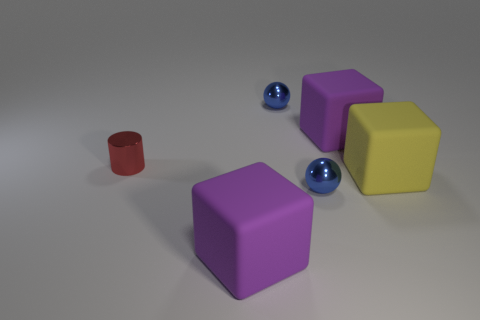Add 2 large brown cylinders. How many objects exist? 8 Subtract all balls. How many objects are left? 4 Subtract 1 yellow blocks. How many objects are left? 5 Subtract all small red metallic things. Subtract all small red shiny cylinders. How many objects are left? 4 Add 5 big yellow cubes. How many big yellow cubes are left? 6 Add 4 purple rubber objects. How many purple rubber objects exist? 6 